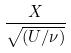<formula> <loc_0><loc_0><loc_500><loc_500>\frac { X } { \sqrt { ( U / \nu ) } }</formula> 